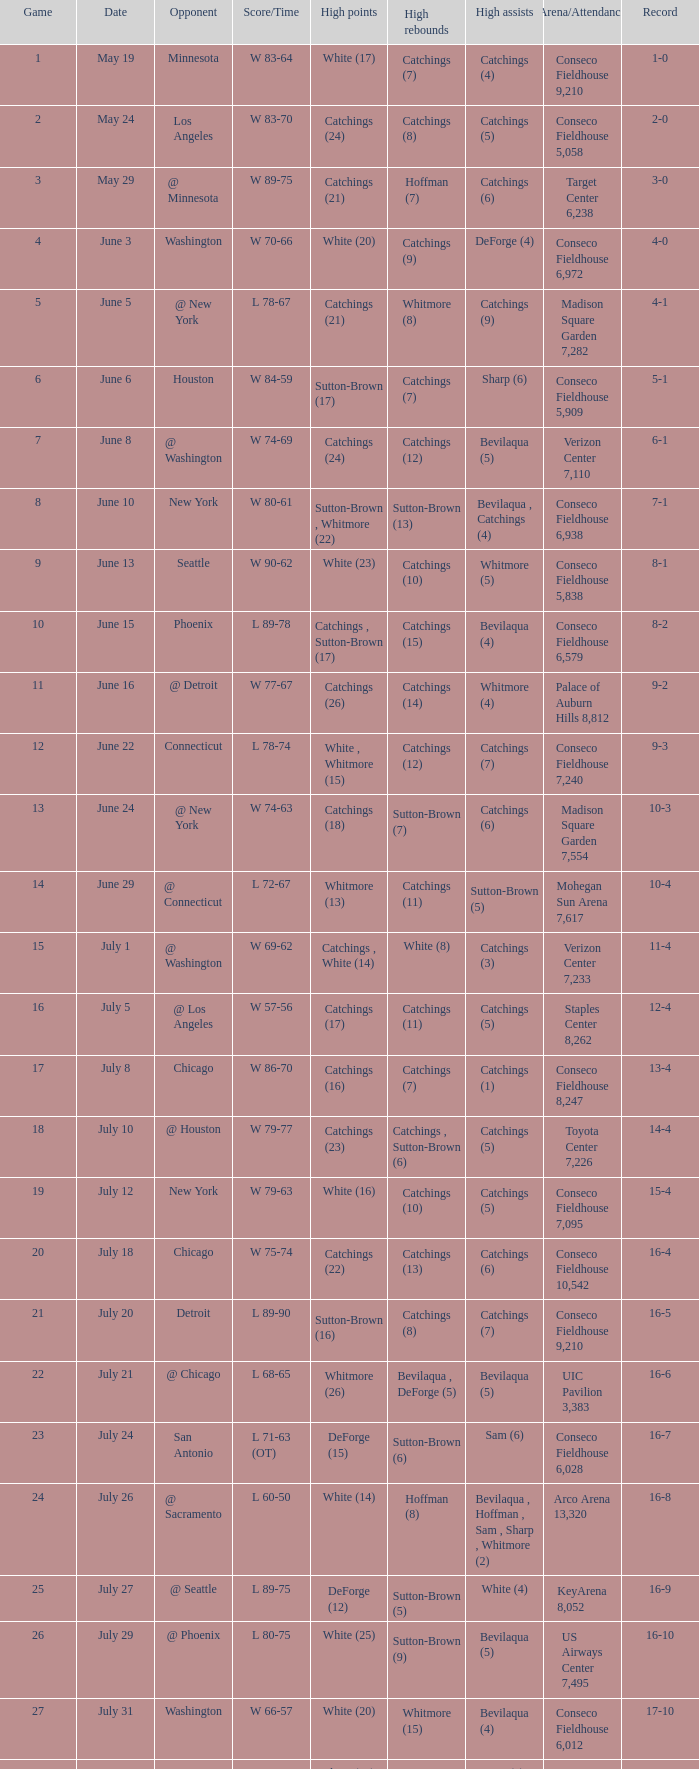Indicate the date where the score time reads w 74-6 June 24. 